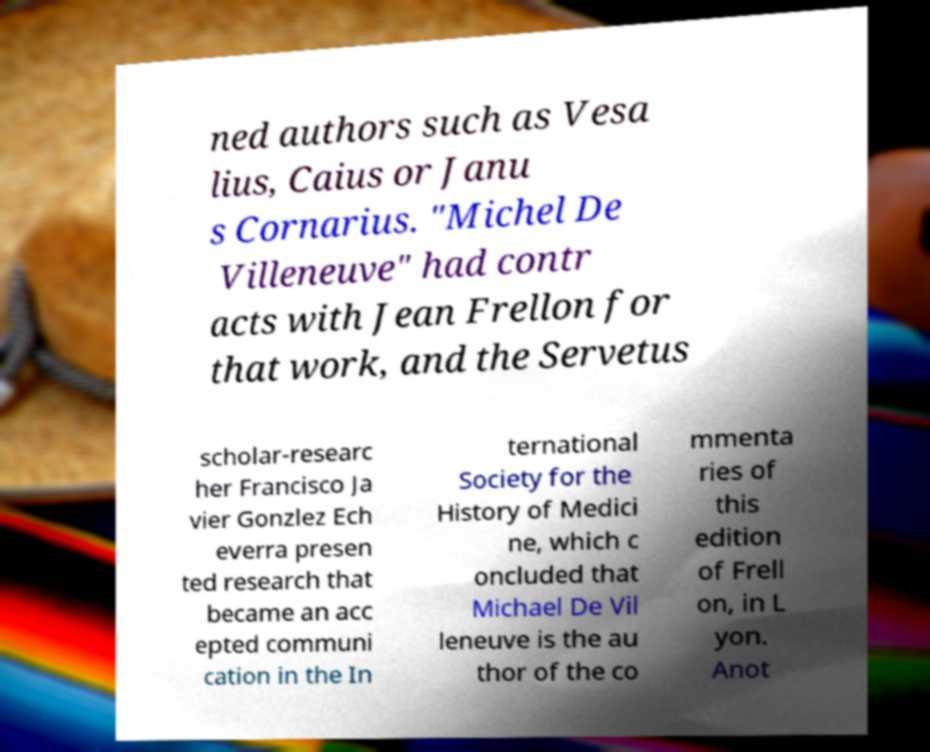Please identify and transcribe the text found in this image. ned authors such as Vesa lius, Caius or Janu s Cornarius. "Michel De Villeneuve" had contr acts with Jean Frellon for that work, and the Servetus scholar-researc her Francisco Ja vier Gonzlez Ech everra presen ted research that became an acc epted communi cation in the In ternational Society for the History of Medici ne, which c oncluded that Michael De Vil leneuve is the au thor of the co mmenta ries of this edition of Frell on, in L yon. Anot 